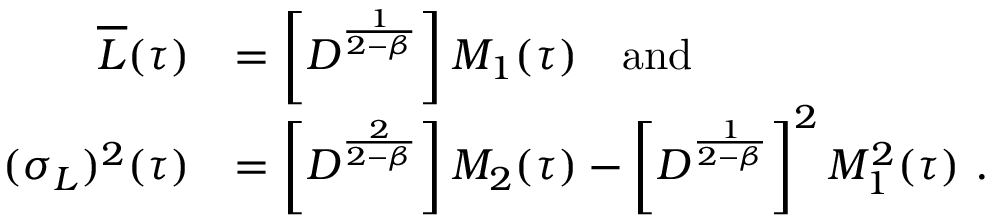Convert formula to latex. <formula><loc_0><loc_0><loc_500><loc_500>\begin{array} { r l } { \overline { L } ( \tau ) } & { = \left [ D ^ { \frac { 1 } { 2 - \beta } } \right ] M _ { 1 } ( \tau ) \quad a n d } \\ { ( \sigma _ { L } ) ^ { 2 } ( \tau ) } & { = \left [ D ^ { \frac { 2 } { 2 - \beta } } \right ] M _ { 2 } ( \tau ) - \left [ D ^ { \frac { 1 } { 2 - \beta } } \right ] ^ { 2 } M _ { 1 } ^ { 2 } ( \tau ) \ . } \end{array}</formula> 